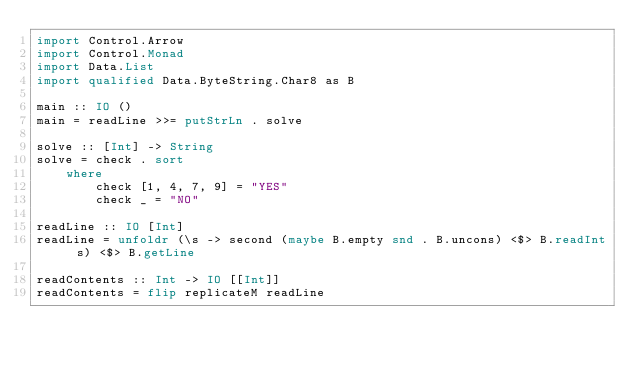<code> <loc_0><loc_0><loc_500><loc_500><_Haskell_>import Control.Arrow
import Control.Monad
import Data.List
import qualified Data.ByteString.Char8 as B

main :: IO ()
main = readLine >>= putStrLn . solve 

solve :: [Int] -> String
solve = check . sort
    where
        check [1, 4, 7, 9] = "YES"
        check _ = "NO"

readLine :: IO [Int]
readLine = unfoldr (\s -> second (maybe B.empty snd . B.uncons) <$> B.readInt s) <$> B.getLine

readContents :: Int -> IO [[Int]]
readContents = flip replicateM readLine</code> 